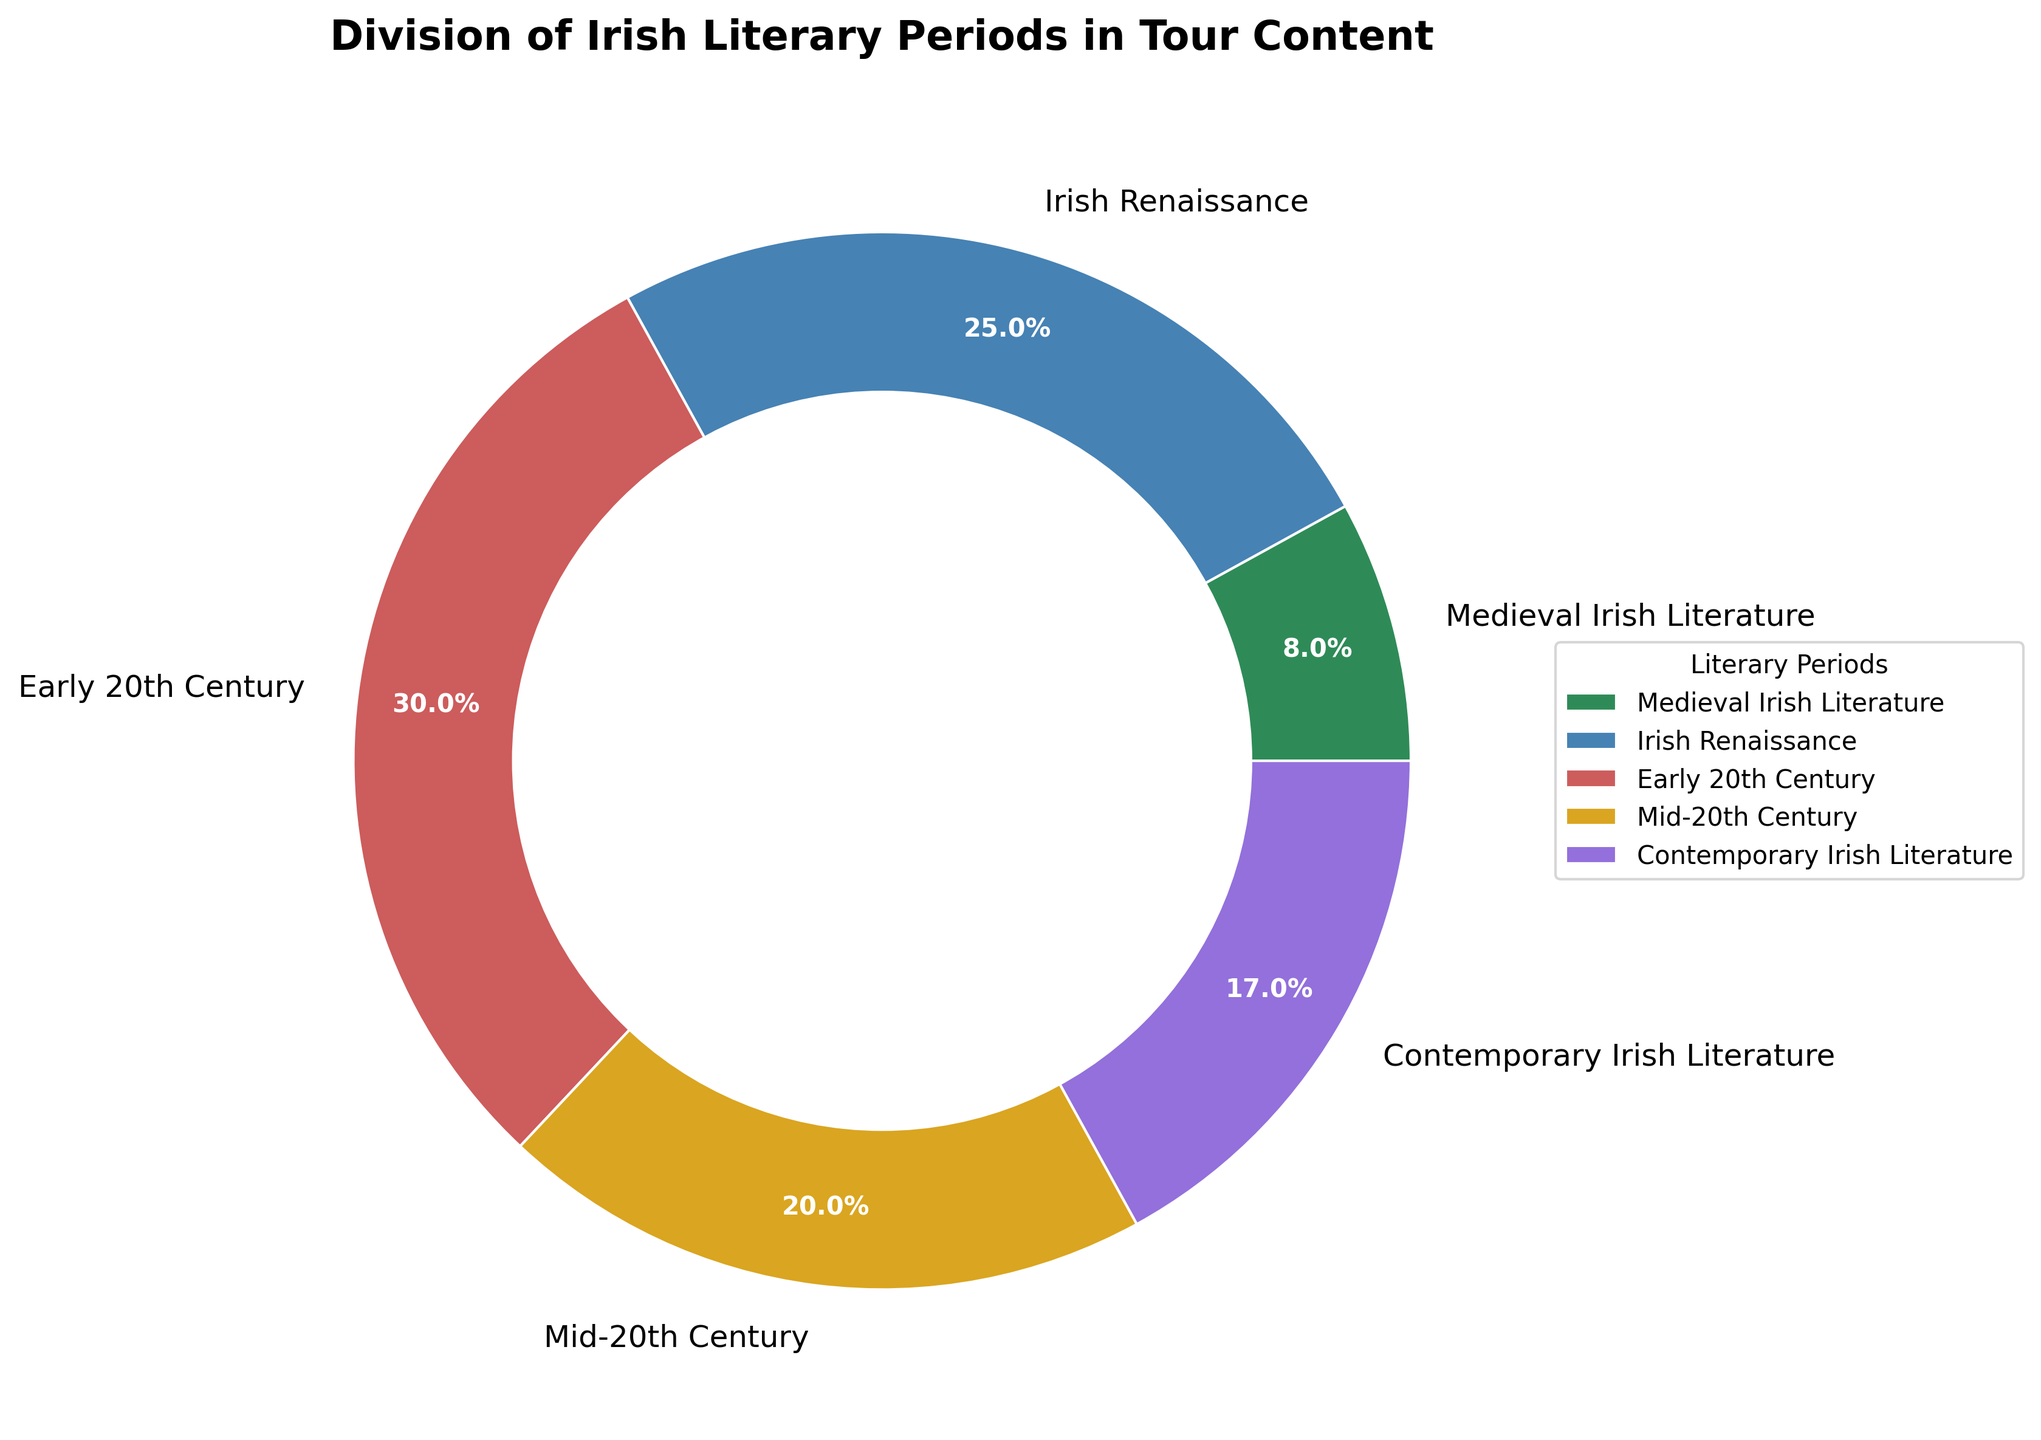What's the oldest literary period represented in the tour content? The oldest literary period can be identified by the name "Medieval Irish Literature" which typically refers to literature from the early Middle Ages.
Answer: Medieval Irish Literature Which period comprises the largest portion of the tour content? The portion with the largest percentage is the Early 20th Century, as it accounts for 30% which is the highest among all periods.
Answer: Early 20th Century What is the percentage difference between the Irish Renaissance and Contemporary Irish Literature? The Irish Renaissance makes up 25% and Contemporary Irish Literature accounts for 17%. The difference is calculated as 25% - 17% = 8%.
Answer: 8% How do the combined percentages of the Mid-20th Century and Medieval Irish Literature compare to the percentage of Early 20th Century? The combined percentages are 20% (Mid-20th Century) + 8% (Medieval Irish Literature) = 28%, which is less than the 30% of the Early 20th Century.
Answer: Less Which periods have percentages that are less than or equal to 20%? By looking at the chart, Medieval Irish Literature (8%) and Mid-20th Century (20%) are the periods with percentages less than or equal to 20%.
Answer: Medieval Irish Literature, Mid-20th Century When combining the Irish Renaissance and Contemporary Irish Literature periods, what fraction of the total do they represent? Combining the Irish Renaissance (25%) and Contemporary Irish Literature (17%) gives 25% + 17% = 42%. As a fraction of the entire 100%, this is 42/100, or simplified, 21/50.
Answer: 21/50 Does the total percentage of Early 20th Century and Irish Renaissance exceed 50%? The percentages for Early 20th Century and Irish Renaissance are 30% and 25% respectively. Adding them gives 30% + 25% = 55%, which exceeds 50%.
Answer: Yes What visual feature helps to easily identify each literary period on the pie chart? Each literary period is identified by a unique color and label directly on the pie chart.
Answer: Colors and Labels Which period, represented by the color green, is included in the tour content? By identifying the colors, the period represented by the color green in the pie chart is Medieval Irish Literature.
Answer: Medieval Irish Literature 